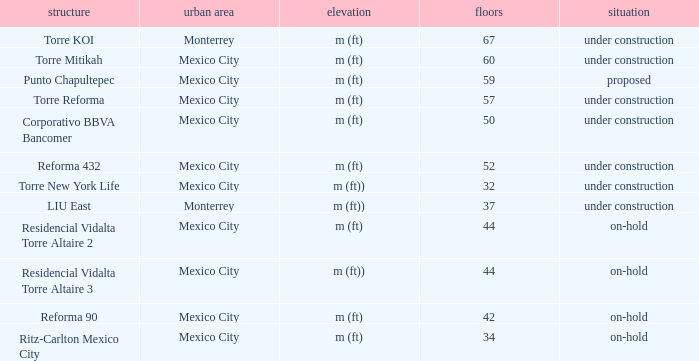How tall is the 52 story building? M (ft). 